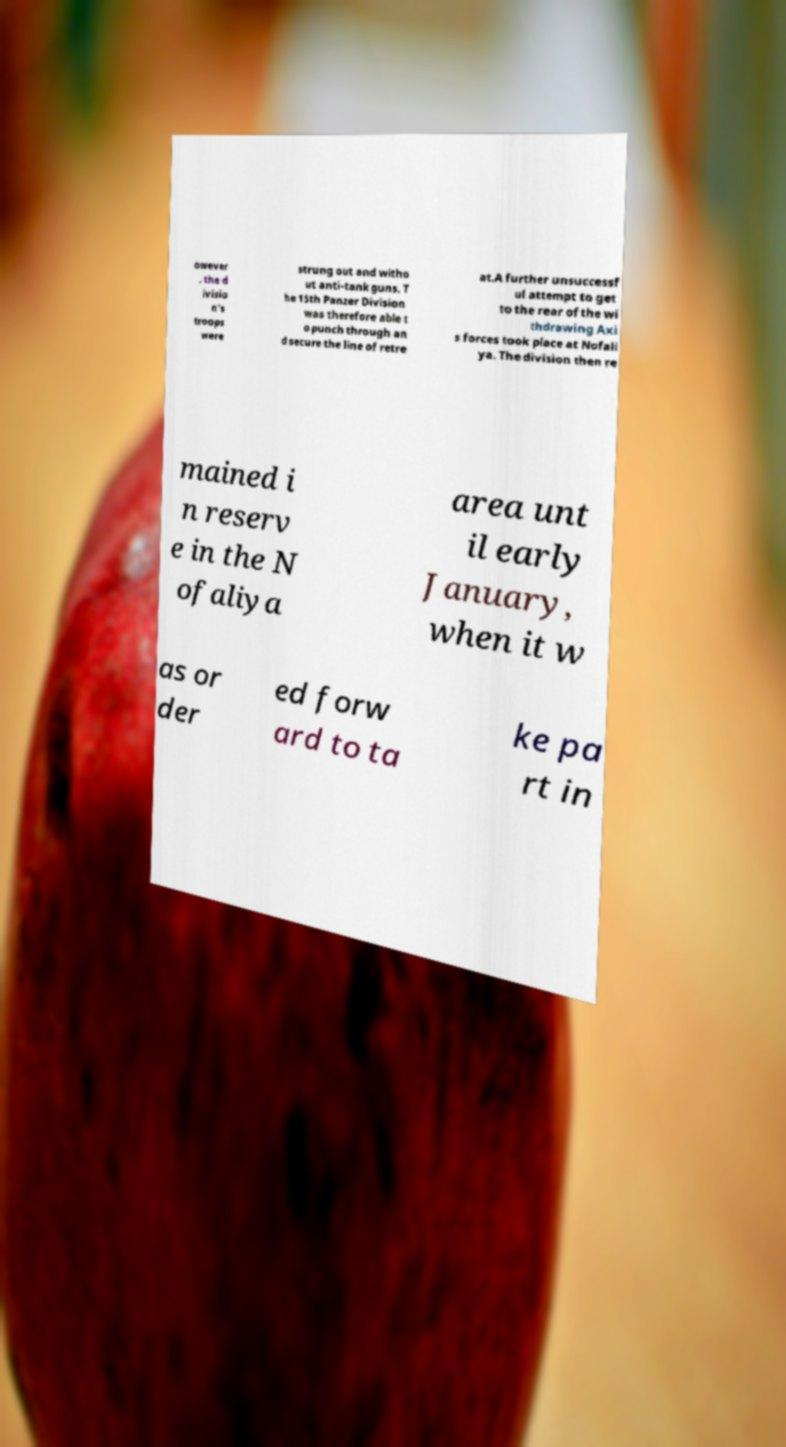Could you extract and type out the text from this image? owever , the d ivisio n's troops were strung out and witho ut anti-tank guns. T he 15th Panzer Division was therefore able t o punch through an d secure the line of retre at.A further unsuccessf ul attempt to get to the rear of the wi thdrawing Axi s forces took place at Nofali ya. The division then re mained i n reserv e in the N ofaliya area unt il early January, when it w as or der ed forw ard to ta ke pa rt in 